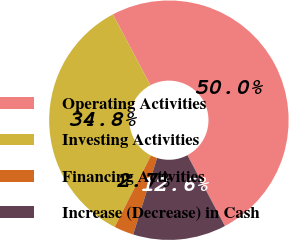<chart> <loc_0><loc_0><loc_500><loc_500><pie_chart><fcel>Operating Activities<fcel>Investing Activities<fcel>Financing Activities<fcel>Increase (Decrease) in Cash<nl><fcel>50.0%<fcel>34.78%<fcel>2.65%<fcel>12.57%<nl></chart> 